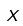Convert formula to latex. <formula><loc_0><loc_0><loc_500><loc_500>X</formula> 